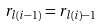Convert formula to latex. <formula><loc_0><loc_0><loc_500><loc_500>r _ { l ( i - 1 ) } = r _ { l ( i ) - 1 }</formula> 